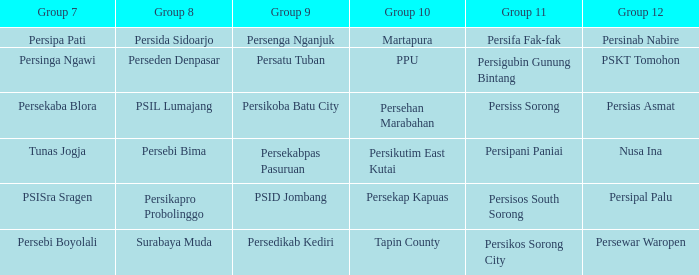Could you parse the entire table as a dict? {'header': ['Group 7', 'Group 8', 'Group 9', 'Group 10', 'Group 11', 'Group 12'], 'rows': [['Persipa Pati', 'Persida Sidoarjo', 'Persenga Nganjuk', 'Martapura', 'Persifa Fak-fak', 'Persinab Nabire'], ['Persinga Ngawi', 'Perseden Denpasar', 'Persatu Tuban', 'PPU', 'Persigubin Gunung Bintang', 'PSKT Tomohon'], ['Persekaba Blora', 'PSIL Lumajang', 'Persikoba Batu City', 'Persehan Marabahan', 'Persiss Sorong', 'Persias Asmat'], ['Tunas Jogja', 'Persebi Bima', 'Persekabpas Pasuruan', 'Persikutim East Kutai', 'Persipani Paniai', 'Nusa Ina'], ['PSISra Sragen', 'Persikapro Probolinggo', 'PSID Jombang', 'Persekap Kapuas', 'Persisos South Sorong', 'Persipal Palu'], ['Persebi Boyolali', 'Surabaya Muda', 'Persedikab Kediri', 'Tapin County', 'Persikos Sorong City', 'Persewar Waropen']]} Who played in group 11 when Persipal Palu played in group 12? Persisos South Sorong. 